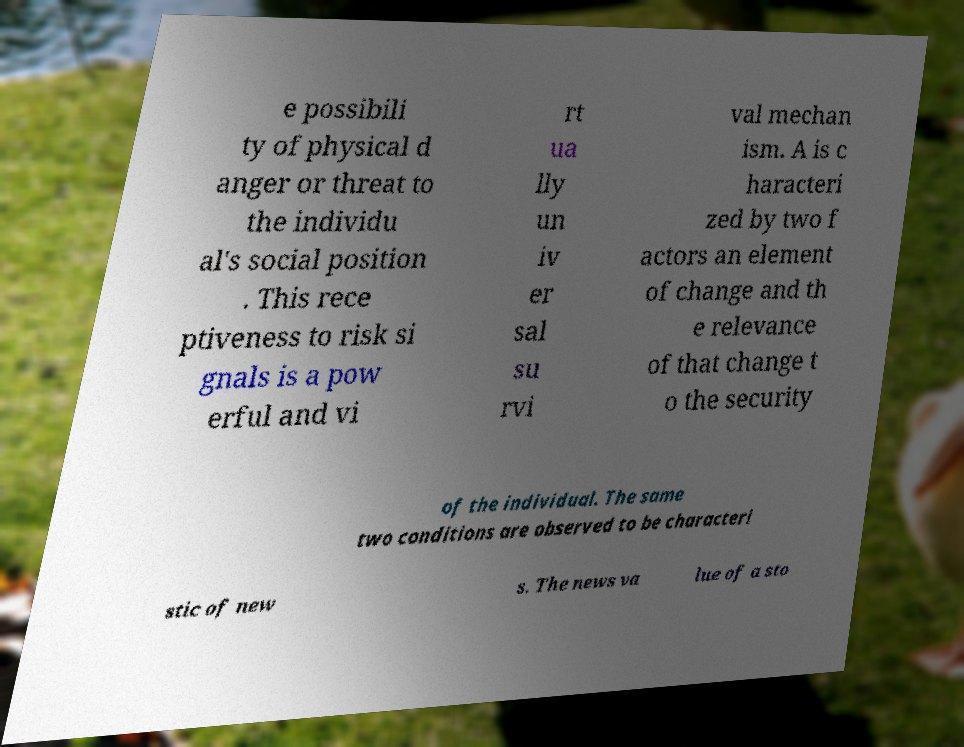Could you assist in decoding the text presented in this image and type it out clearly? e possibili ty of physical d anger or threat to the individu al's social position . This rece ptiveness to risk si gnals is a pow erful and vi rt ua lly un iv er sal su rvi val mechan ism. A is c haracteri zed by two f actors an element of change and th e relevance of that change t o the security of the individual. The same two conditions are observed to be characteri stic of new s. The news va lue of a sto 